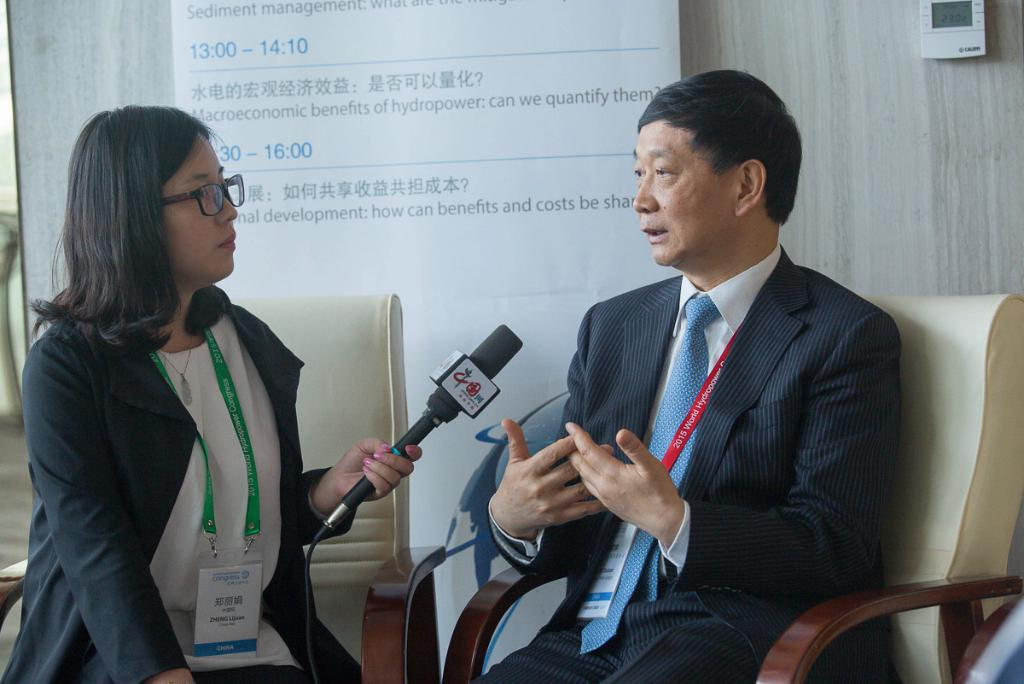Who is the main subject in the image? There is a lady in the image. What is the lady holding in the image? The lady is holding a mic. What is the lady's position in the image? The lady is sitting. Can you describe the other person in the image? The other person is wearing a suit. How many mice can be seen running around the lady in the image? There are no mice present in the image. Is there a giraffe visible in the background of the image? There is no giraffe present in the image. 